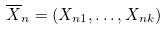Convert formula to latex. <formula><loc_0><loc_0><loc_500><loc_500>\overline { X } _ { n } = ( X _ { n 1 } , \dots , X _ { n k } )</formula> 